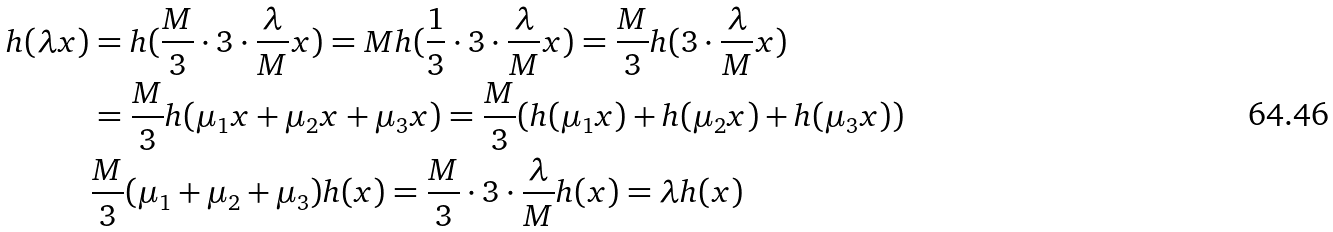<formula> <loc_0><loc_0><loc_500><loc_500>h ( \lambda { x } ) & = h ( \frac { M } { 3 } \cdot 3 \cdot \frac { \lambda } { M } x ) = M h ( \frac { 1 } { 3 } \cdot 3 \cdot \frac { \lambda } { M } x ) = \frac { M } { 3 } h ( 3 \cdot \frac { \lambda } { M } x ) \\ & = \frac { M } { 3 } h ( \mu _ { 1 } x + \mu _ { 2 } x + \mu _ { 3 } x ) = \frac { M } { 3 } ( h ( \mu _ { 1 } x ) + h ( \mu _ { 2 } x ) + h ( \mu _ { 3 } x ) ) \\ & \frac { M } { 3 } ( \mu _ { 1 } + \mu _ { 2 } + \mu _ { 3 } ) h ( x ) = \frac { M } { 3 } \cdot 3 \cdot \frac { \lambda } { M } h ( x ) = \lambda h ( x )</formula> 